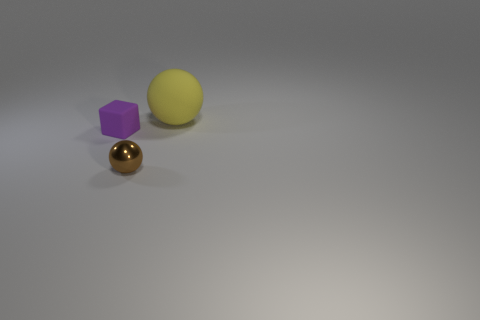Subtract all brown balls. How many balls are left? 1 Subtract 1 cubes. How many cubes are left? 0 Add 2 tiny purple things. How many objects exist? 5 Subtract all cubes. How many objects are left? 2 Subtract all green blocks. Subtract all purple cylinders. How many blocks are left? 1 Subtract all big yellow matte balls. Subtract all balls. How many objects are left? 0 Add 1 small brown objects. How many small brown objects are left? 2 Add 3 small spheres. How many small spheres exist? 4 Subtract 0 blue balls. How many objects are left? 3 